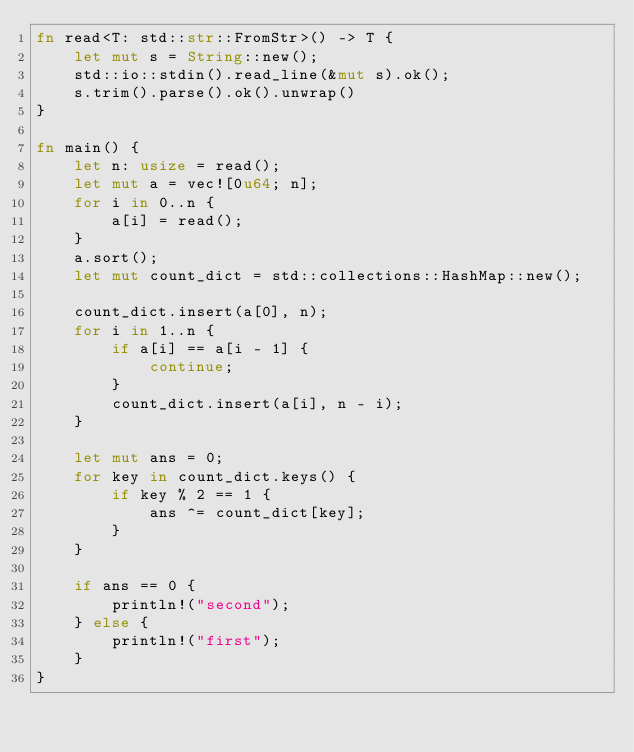<code> <loc_0><loc_0><loc_500><loc_500><_Rust_>fn read<T: std::str::FromStr>() -> T {
    let mut s = String::new();
    std::io::stdin().read_line(&mut s).ok();
    s.trim().parse().ok().unwrap()
}

fn main() {
    let n: usize = read();
    let mut a = vec![0u64; n];
    for i in 0..n {
        a[i] = read();
    }
    a.sort();
    let mut count_dict = std::collections::HashMap::new();

    count_dict.insert(a[0], n);
    for i in 1..n {
        if a[i] == a[i - 1] {
            continue;
        }
        count_dict.insert(a[i], n - i);
    }

    let mut ans = 0;
    for key in count_dict.keys() {
        if key % 2 == 1 {
            ans ^= count_dict[key];
        }
    }

    if ans == 0 {
        println!("second");
    } else {
        println!("first");
    }
}
</code> 